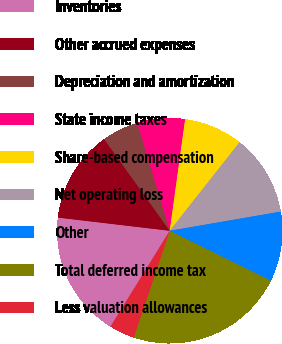Convert chart to OTSL. <chart><loc_0><loc_0><loc_500><loc_500><pie_chart><fcel>Inventories<fcel>Other accrued expenses<fcel>Depreciation and amortization<fcel>State income taxes<fcel>Share-based compensation<fcel>Net operating loss<fcel>Other<fcel>Total deferred income tax<fcel>Less valuation allowances<nl><fcel>18.06%<fcel>13.25%<fcel>5.23%<fcel>6.84%<fcel>8.44%<fcel>11.65%<fcel>10.04%<fcel>22.87%<fcel>3.63%<nl></chart> 